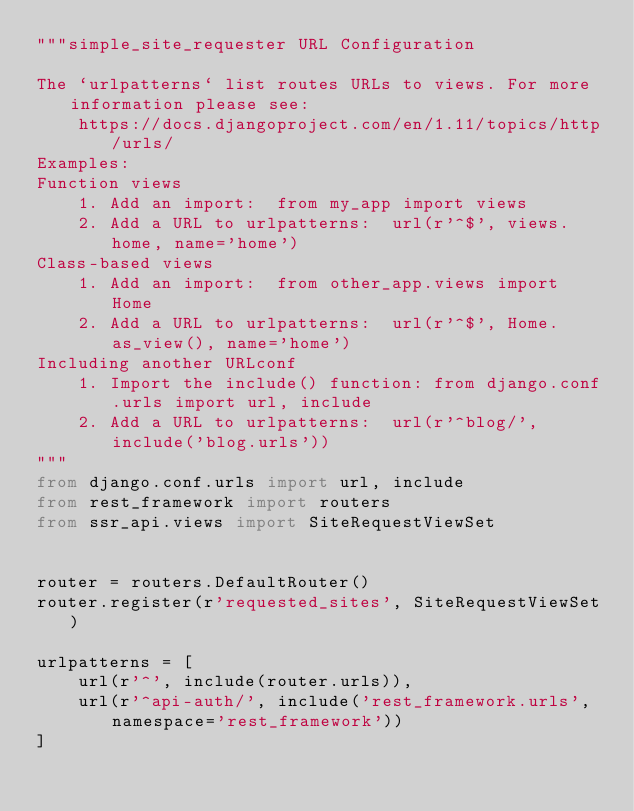Convert code to text. <code><loc_0><loc_0><loc_500><loc_500><_Python_>"""simple_site_requester URL Configuration

The `urlpatterns` list routes URLs to views. For more information please see:
    https://docs.djangoproject.com/en/1.11/topics/http/urls/
Examples:
Function views
    1. Add an import:  from my_app import views
    2. Add a URL to urlpatterns:  url(r'^$', views.home, name='home')
Class-based views
    1. Add an import:  from other_app.views import Home
    2. Add a URL to urlpatterns:  url(r'^$', Home.as_view(), name='home')
Including another URLconf
    1. Import the include() function: from django.conf.urls import url, include
    2. Add a URL to urlpatterns:  url(r'^blog/', include('blog.urls'))
"""
from django.conf.urls import url, include
from rest_framework import routers
from ssr_api.views import SiteRequestViewSet


router = routers.DefaultRouter()
router.register(r'requested_sites', SiteRequestViewSet)

urlpatterns = [
    url(r'^', include(router.urls)),
    url(r'^api-auth/', include('rest_framework.urls', namespace='rest_framework'))
]
</code> 